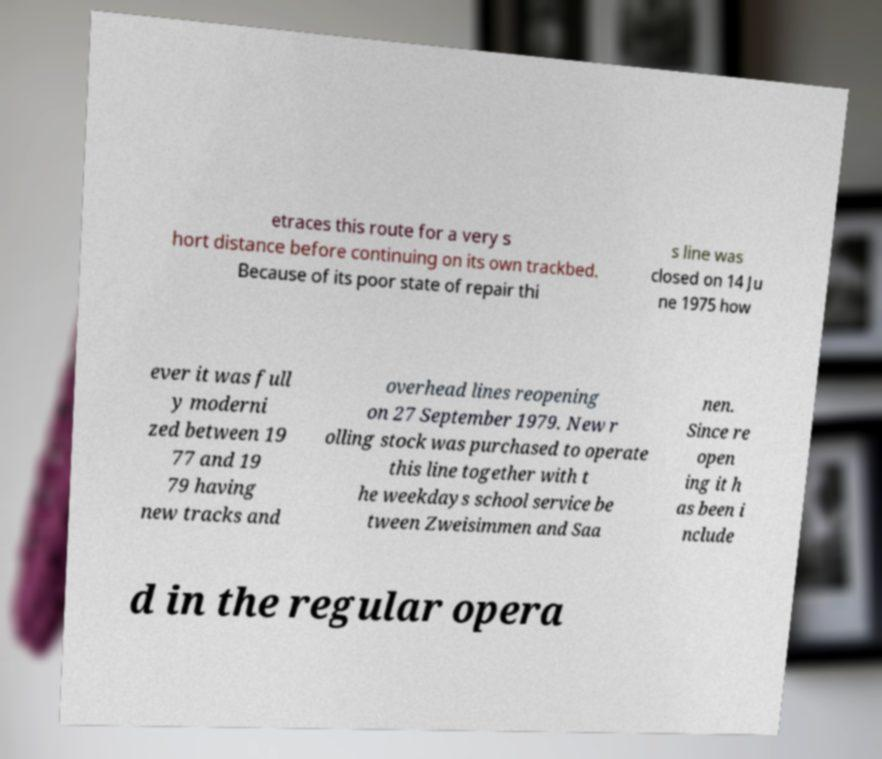Can you accurately transcribe the text from the provided image for me? etraces this route for a very s hort distance before continuing on its own trackbed. Because of its poor state of repair thi s line was closed on 14 Ju ne 1975 how ever it was full y moderni zed between 19 77 and 19 79 having new tracks and overhead lines reopening on 27 September 1979. New r olling stock was purchased to operate this line together with t he weekdays school service be tween Zweisimmen and Saa nen. Since re open ing it h as been i nclude d in the regular opera 